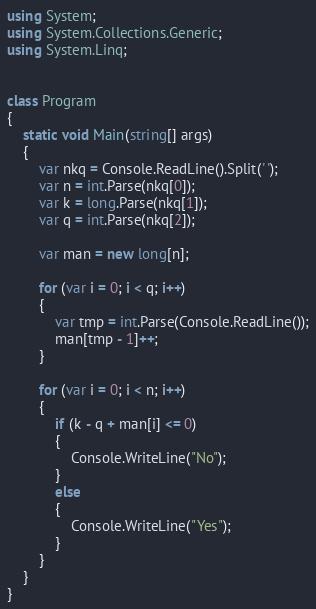<code> <loc_0><loc_0><loc_500><loc_500><_C#_>using System;
using System.Collections.Generic;
using System.Linq;


class Program
{
    static void Main(string[] args)
    {
        var nkq = Console.ReadLine().Split(' ');
        var n = int.Parse(nkq[0]);
        var k = long.Parse(nkq[1]);
        var q = int.Parse(nkq[2]);

        var man = new long[n];

        for (var i = 0; i < q; i++)
        {
            var tmp = int.Parse(Console.ReadLine());
            man[tmp - 1]++;
        }

        for (var i = 0; i < n; i++)
        {
            if (k - q + man[i] <= 0)
            {
                Console.WriteLine("No");
            }
            else
            {
                Console.WriteLine("Yes");
            }
        }
    }
}


</code> 